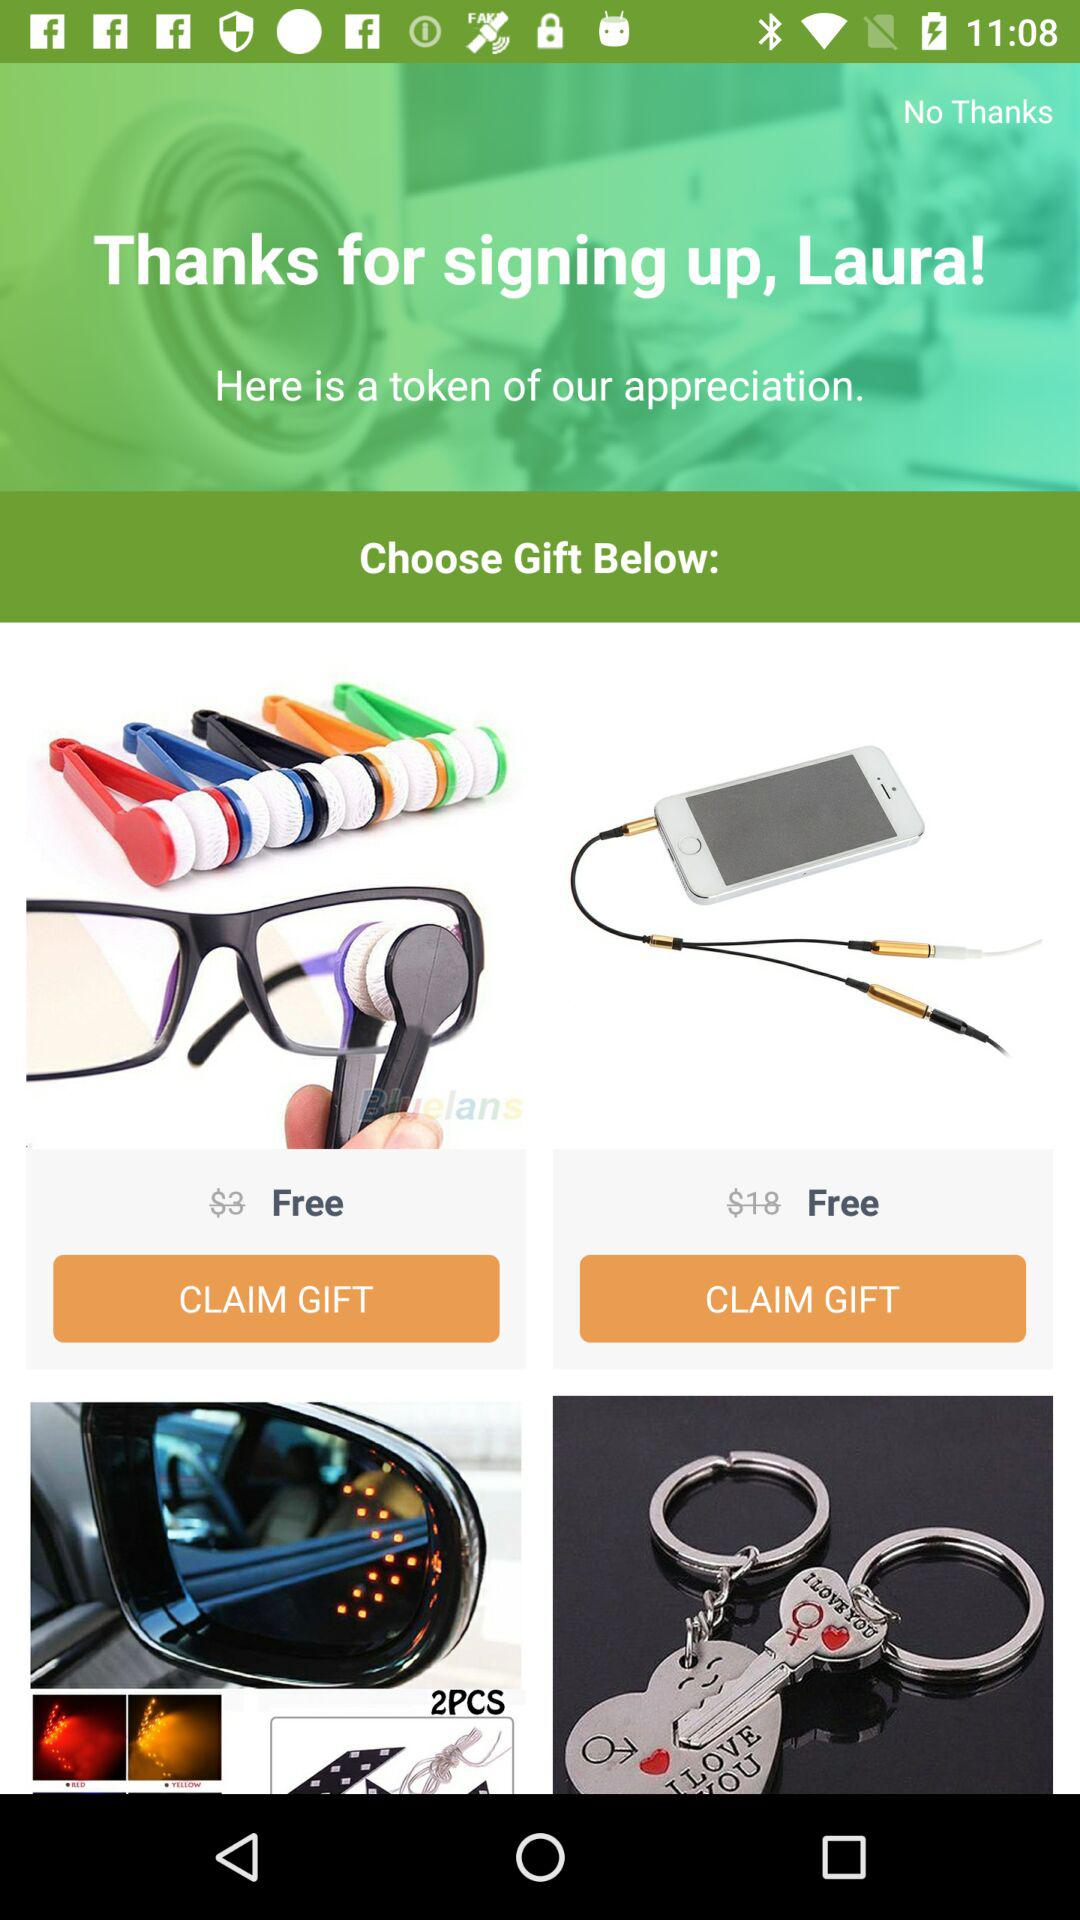How many gifts are there?
Answer the question using a single word or phrase. 4 